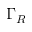<formula> <loc_0><loc_0><loc_500><loc_500>\Gamma _ { R }</formula> 